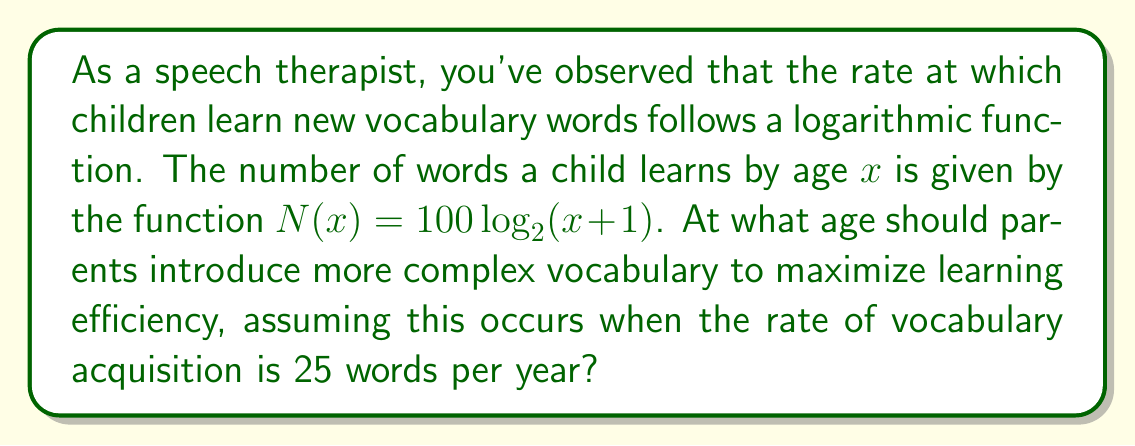Teach me how to tackle this problem. To solve this problem, we need to follow these steps:

1) The rate of vocabulary acquisition is given by the derivative of $N(x)$ with respect to $x$. Let's call this $N'(x)$.

2) Calculate $N'(x)$:
   $$N'(x) = \frac{d}{dx}[100 \log_2(x + 1)]$$
   $$N'(x) = 100 \cdot \frac{1}{(x+1) \ln 2}$$

3) We want to find $x$ when $N'(x) = 25$. Set up the equation:
   $$25 = 100 \cdot \frac{1}{(x+1) \ln 2}$$

4) Solve for $x$:
   $$25(x+1) \ln 2 = 100$$
   $$x+1 = \frac{100}{25 \ln 2}$$
   $$x = \frac{100}{25 \ln 2} - 1$$
   $$x = \frac{4}{\ln 2} - 1$$

5) Calculate the value (rounded to 2 decimal places):
   $$x \approx 5.77 - 1 = 4.77$$

Therefore, parents should introduce more complex vocabulary when the child is approximately 4.77 years old to maximize learning efficiency.
Answer: 4.77 years 